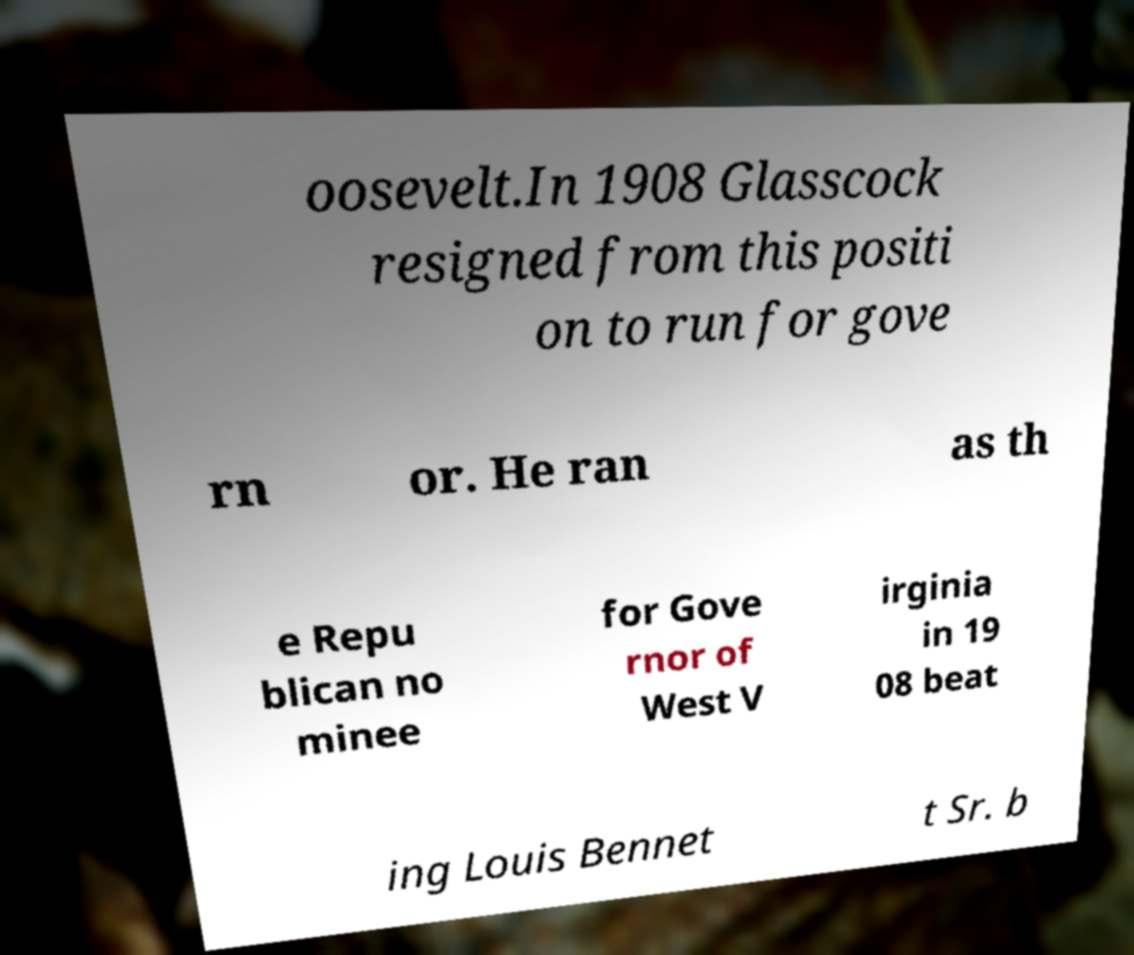Could you extract and type out the text from this image? oosevelt.In 1908 Glasscock resigned from this positi on to run for gove rn or. He ran as th e Repu blican no minee for Gove rnor of West V irginia in 19 08 beat ing Louis Bennet t Sr. b 